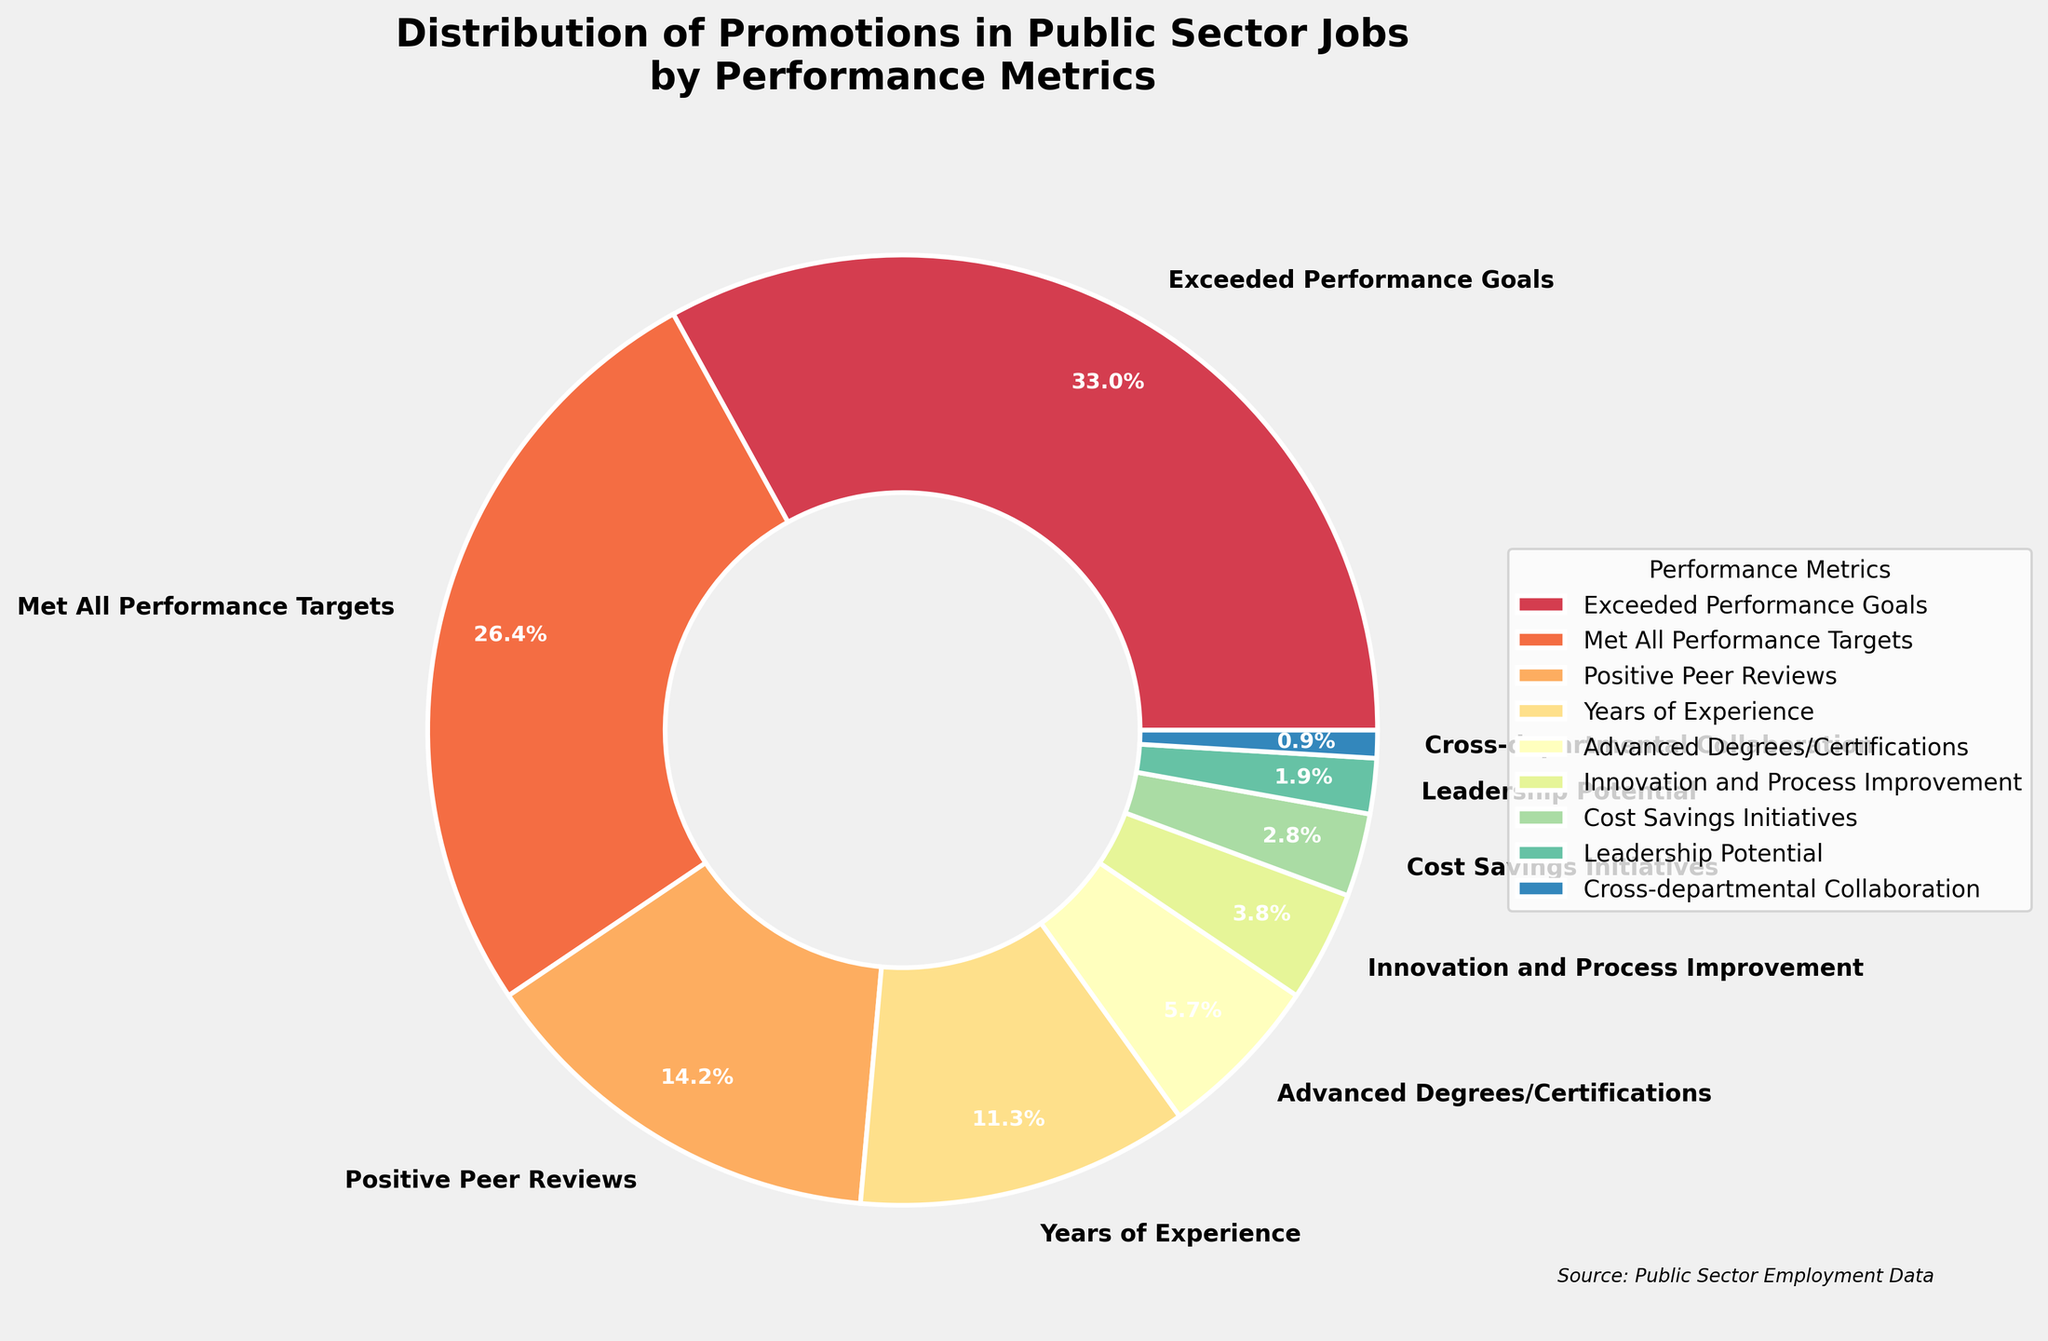Which performance metric has the highest percentage of promotions? The highest percentage segment in the pie chart represents the metric "Exceeded Performance Goals" at 35%.
Answer: Exceeded Performance Goals How much more percentage of promotions is associated with "Met All Performance Targets" compared to "Positive Peer Reviews"? The percentage for "Met All Performance Targets" is 28%, and for "Positive Peer Reviews" it is 15%. The difference is calculated as 28% - 15% = 13%.
Answer: 13% What is the combined percentage of promotions for "Innovation and Process Improvement" and "Cost Savings Initiatives"? The percentage for "Innovation and Process Improvement" is 4%, and for "Cost Savings Initiatives" it is 3%. Adding these gives 4% + 3% = 7%.
Answer: 7% Compare the promotion percentages for "Years of Experience" and "Advanced Degrees/Certifications". Which one is higher and by how much? "Years of Experience" has a percentage of 12% and "Advanced Degrees/Certifications" has 6%. The difference is 12% - 6% = 6%, making "Years of Experience" higher by 6%.
Answer: Years of Experience by 6% What percentage of promotions is attributed to metrics other than "Exceeded Performance Goals" and "Met All Performance Targets"? First, add the percentages of "Exceeded Performance Goals" and "Met All Performance Targets": 35% + 28% = 63%. Then subtract this from 100% to get 100% - 63% = 37%.
Answer: 37% Which metric occupies the smallest area on the pie chart? The smallest segment in the pie chart represents "Cross-departmental Collaboration" at 1%.
Answer: Cross-departmental Collaboration What is the total percentage of promotions accounted for by the top three performance metrics? The top three metrics are "Exceeded Performance Goals" (35%), "Met All Performance Targets" (28%), and "Positive Peer Reviews" (15%). Summing these gives 35% + 28% + 15% = 78%.
Answer: 78% How do the percentages of "Leadership Potential" and "Cross-departmental Collaboration" compare visually? Visually, the segment for "Leadership Potential" is larger than the segment for "Cross-departmental Collaboration". Specifically, "Leadership Potential" is 2% while "Cross-departmental Collaboration" is 1%, indicating the difference in size.
Answer: Leadership Potential is larger What percentage of promotions is attributed to metrics focused on achievements (Exceeded Performance Goals, Met All Performance Targets, Positive Peer Reviews)? Adding the percentages for "Exceeded Performance Goals" (35%), "Met All Performance Targets" (28%), and "Positive Peer Reviews" (15%) gives 35% + 28% + 15% = 78%.
Answer: 78% 